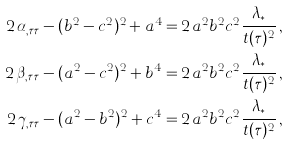Convert formula to latex. <formula><loc_0><loc_0><loc_500><loc_500>2 \, \alpha _ { , \tau \tau } - ( b ^ { 2 } - c ^ { 2 } ) ^ { 2 } + a ^ { 4 } = & \, 2 \, a ^ { 2 } b ^ { 2 } c ^ { 2 } \frac { \lambda _ { * } } { t ( \tau ) ^ { 2 } } \, , \\ 2 \, \beta _ { , \tau \tau } - ( a ^ { 2 } - c ^ { 2 } ) ^ { 2 } + b ^ { 4 } = & \, 2 \, a ^ { 2 } b ^ { 2 } c ^ { 2 } \frac { \lambda _ { * } } { t ( \tau ) ^ { 2 } } \, , \\ 2 \, \gamma _ { , \tau \tau } - ( a ^ { 2 } - b ^ { 2 } ) ^ { 2 } + c ^ { 4 } = & \, 2 \, a ^ { 2 } b ^ { 2 } c ^ { 2 } \frac { \lambda _ { * } } { t ( \tau ) ^ { 2 } } \, ,</formula> 